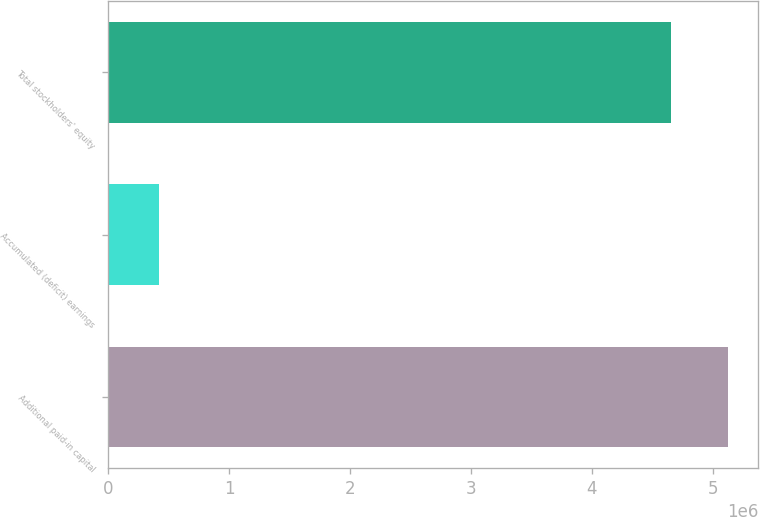Convert chart. <chart><loc_0><loc_0><loc_500><loc_500><bar_chart><fcel>Additional paid-in capital<fcel>Accumulated (deficit) earnings<fcel>Total stockholders' equity<nl><fcel>5.12086e+06<fcel>419053<fcel>4.65533e+06<nl></chart> 